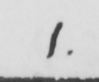Can you read and transcribe this handwriting? 1 . 